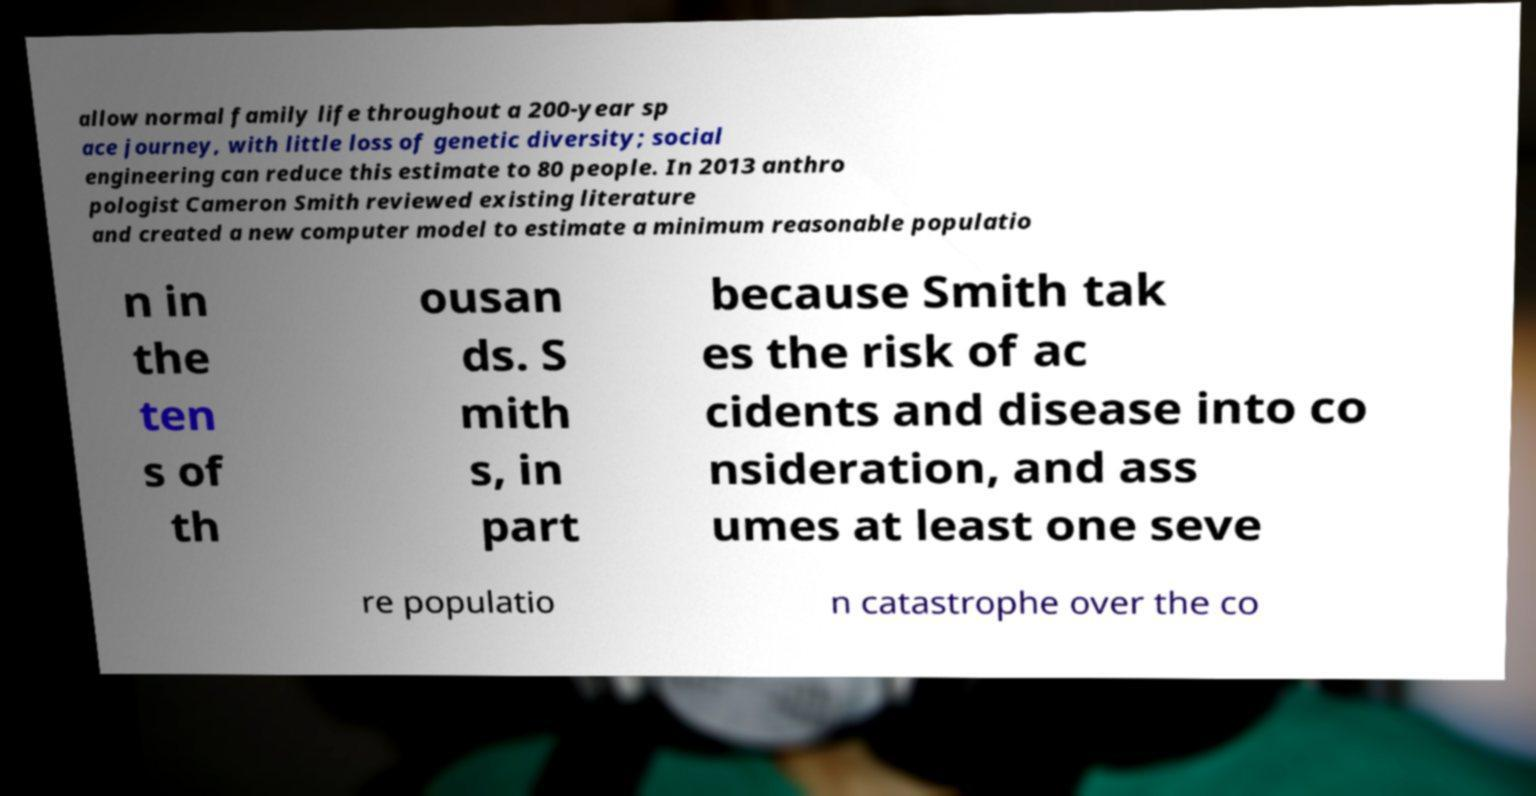Could you extract and type out the text from this image? allow normal family life throughout a 200-year sp ace journey, with little loss of genetic diversity; social engineering can reduce this estimate to 80 people. In 2013 anthro pologist Cameron Smith reviewed existing literature and created a new computer model to estimate a minimum reasonable populatio n in the ten s of th ousan ds. S mith s, in part because Smith tak es the risk of ac cidents and disease into co nsideration, and ass umes at least one seve re populatio n catastrophe over the co 